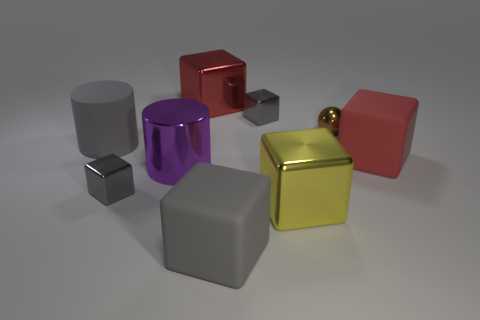Subtract all gray blocks. How many blocks are left? 3 Subtract all metal cubes. How many cubes are left? 2 Subtract all balls. How many objects are left? 8 Subtract 1 spheres. How many spheres are left? 0 Subtract all red cylinders. Subtract all cyan blocks. How many cylinders are left? 2 Subtract all red blocks. How many gray cylinders are left? 1 Subtract all small blue cylinders. Subtract all gray cubes. How many objects are left? 6 Add 5 small blocks. How many small blocks are left? 7 Add 1 yellow shiny blocks. How many yellow shiny blocks exist? 2 Subtract 1 gray blocks. How many objects are left? 8 